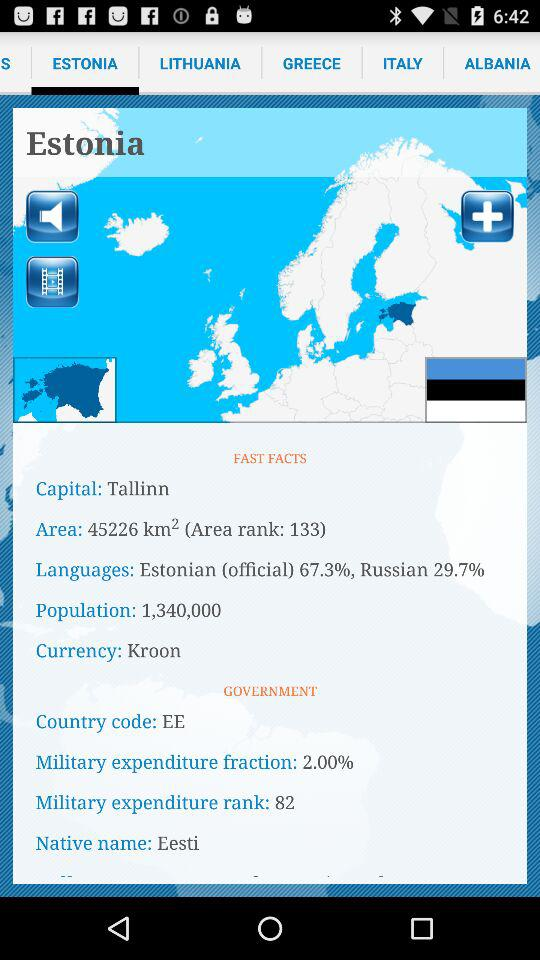What's the country code? The country code is EE. 